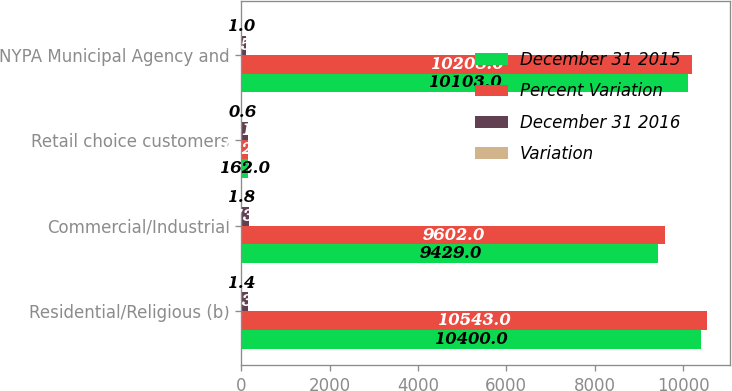Convert chart. <chart><loc_0><loc_0><loc_500><loc_500><stacked_bar_chart><ecel><fcel>Residential/Religious (b)<fcel>Commercial/Industrial<fcel>Retail choice customers<fcel>NYPA Municipal Agency and<nl><fcel>December 31 2015<fcel>10400<fcel>9429<fcel>162<fcel>10103<nl><fcel>Percent Variation<fcel>10543<fcel>9602<fcel>162<fcel>10208<nl><fcel>December 31 2016<fcel>143<fcel>173<fcel>151<fcel>105<nl><fcel>Variation<fcel>1.4<fcel>1.8<fcel>0.6<fcel>1<nl></chart> 